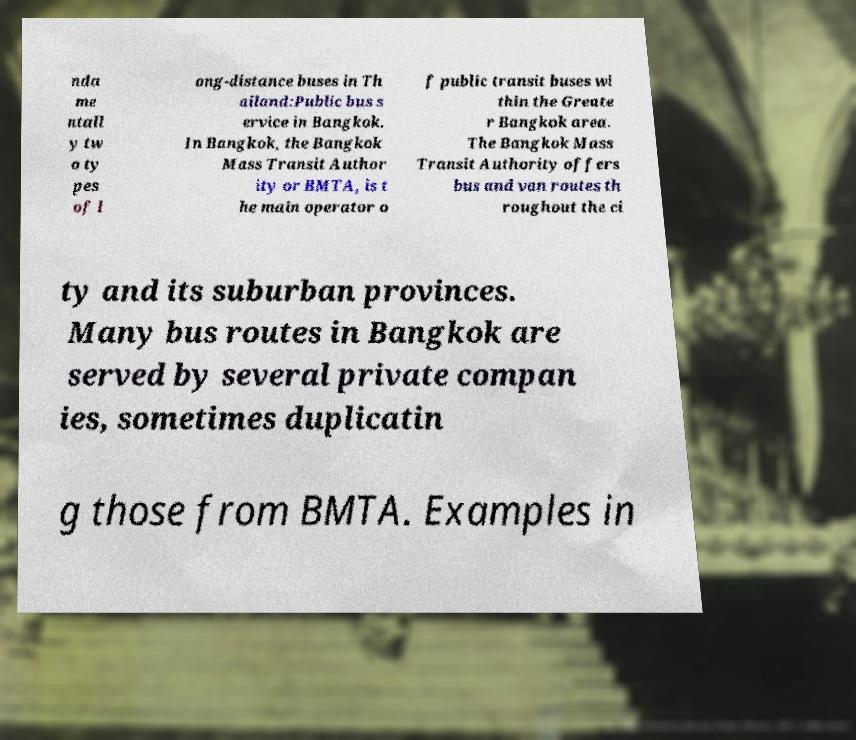Please read and relay the text visible in this image. What does it say? nda me ntall y tw o ty pes of l ong-distance buses in Th ailand:Public bus s ervice in Bangkok. In Bangkok, the Bangkok Mass Transit Author ity or BMTA, is t he main operator o f public transit buses wi thin the Greate r Bangkok area. The Bangkok Mass Transit Authority offers bus and van routes th roughout the ci ty and its suburban provinces. Many bus routes in Bangkok are served by several private compan ies, sometimes duplicatin g those from BMTA. Examples in 